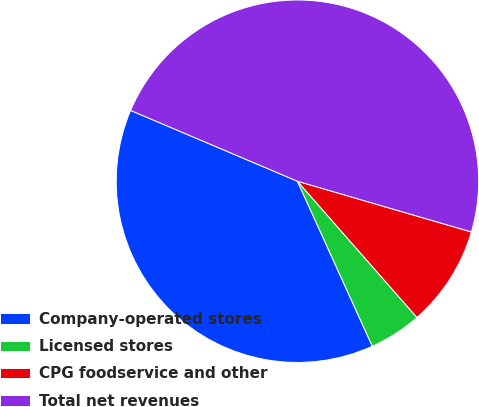Convert chart. <chart><loc_0><loc_0><loc_500><loc_500><pie_chart><fcel>Company-operated stores<fcel>Licensed stores<fcel>CPG foodservice and other<fcel>Total net revenues<nl><fcel>38.17%<fcel>4.68%<fcel>9.02%<fcel>48.13%<nl></chart> 